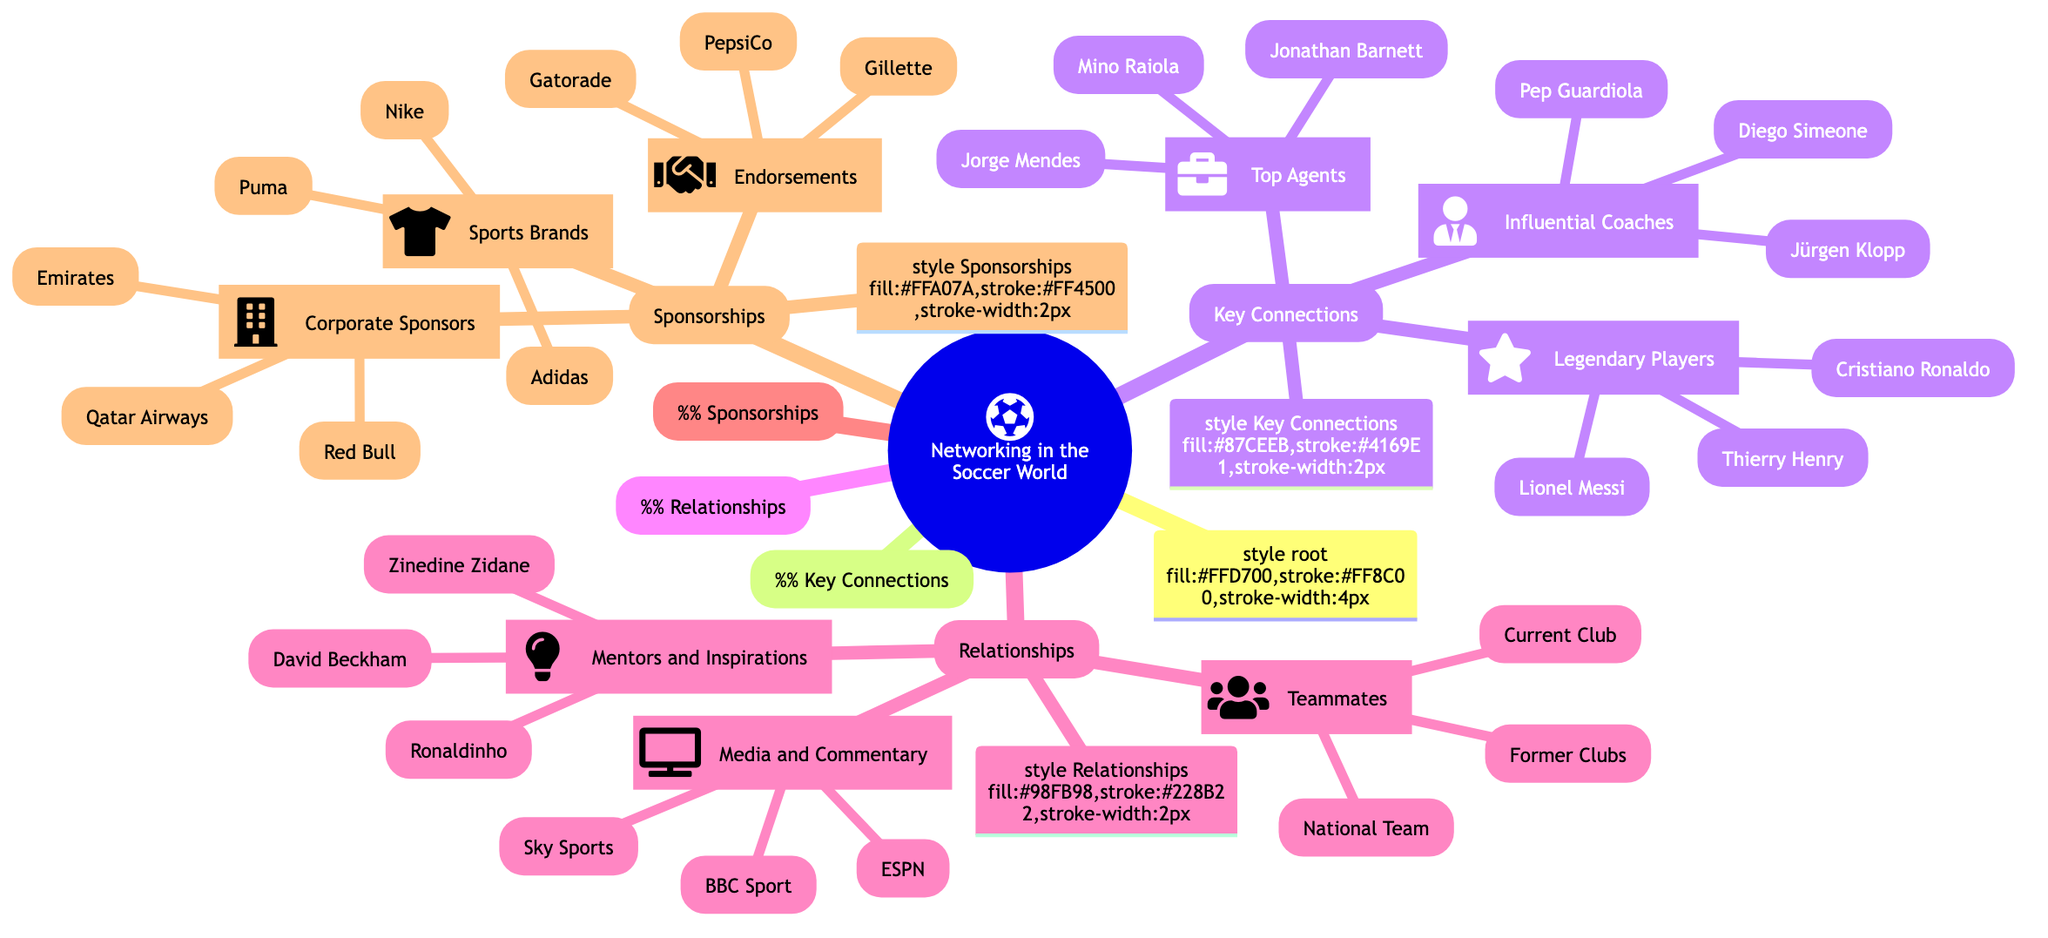What are the three top agents listed in the diagram? The diagram shows the section titled "Top Agents" under "Key Connections," which includes Jorge Mendes, Mino Raiola, and Jonathan Barnett.
Answer: Jorge Mendes, Mino Raiola, Jonathan Barnett Who are the influential coaches in the soccer networking? The influential coaches listed in the "Key Connections" section include Pep Guardiola, Jürgen Klopp, and Diego Simeone.
Answer: Pep Guardiola, Jürgen Klopp, Diego Simeone How many categories are there in the "Sponsorships" section? In the "Sponsorships" section, there are three categories: Sports Brands, Corporate Sponsors, and Endorsements.
Answer: 3 Which players are classified as legendary players in the networking diagram? The diagram lists Lionel Messi, Cristiano Ronaldo, and Thierry Henry under the "Legendary Players" category in "Key Connections."
Answer: Lionel Messi, Cristiano Ronaldo, Thierry Henry What type of media outlets are mentioned in the Relationships section? The media outlets mentioned in the "Media and Commentary" category include Sky Sports, ESPN, and BBC Sport, which categorize the type of relationships.
Answer: Sky Sports, ESPN, BBC Sport Which soccer star is listed as a mentor? The "Mentors and Inspirations" section includes Zinedine Zidane, Ronaldinho, and David Beckham as prominent figures for players.
Answer: Zinedine Zidane How many influential coaches are mentioned in total? The total number of influential coaches listed in the "Influential Coaches" section is three: Pep Guardiola, Jürgen Klopp, and Diego Simeone.
Answer: 3 What is a common corporate sponsor for soccer clubs according to the diagram? The corporate sponsors include Emirates, Qatar Airways, and Red Bull, which are commonly associated with soccer branding.
Answer: Emirates Which is one of the three sports brands listed as sponsorships? The diagram features three sports brands, including Nike, Adidas, and Puma.
Answer: Nike 